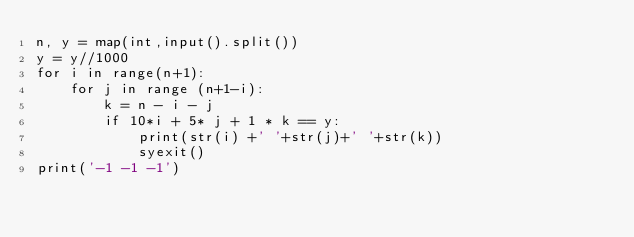Convert code to text. <code><loc_0><loc_0><loc_500><loc_500><_Python_>n, y = map(int,input().split())
y = y//1000
for i in range(n+1):
    for j in range (n+1-i):
        k = n - i - j
        if 10*i + 5* j + 1 * k == y:
            print(str(i) +' '+str(j)+' '+str(k))
            syexit()
print('-1 -1 -1')</code> 